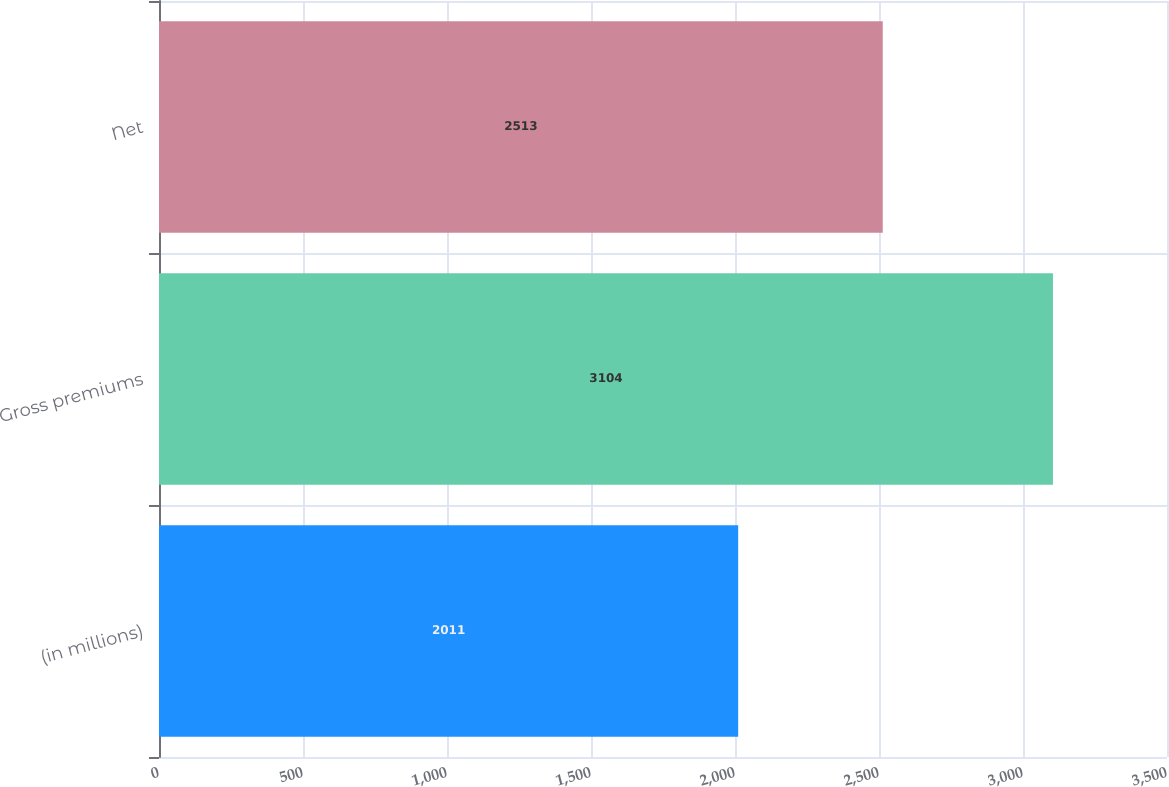<chart> <loc_0><loc_0><loc_500><loc_500><bar_chart><fcel>(in millions)<fcel>Gross premiums<fcel>Net<nl><fcel>2011<fcel>3104<fcel>2513<nl></chart> 